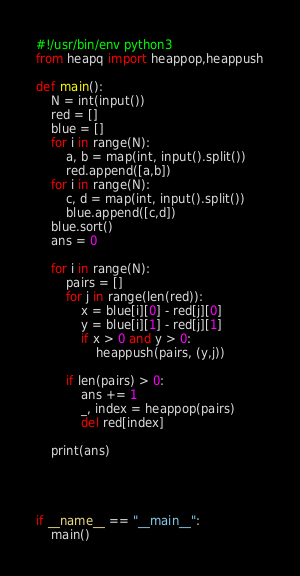<code> <loc_0><loc_0><loc_500><loc_500><_Python_>#!/usr/bin/env python3
from heapq import heappop,heappush

def main():
    N = int(input())
    red = []
    blue = []
    for i in range(N):
        a, b = map(int, input().split())
        red.append([a,b])
    for i in range(N):
        c, d = map(int, input().split())
        blue.append([c,d])
    blue.sort()
    ans = 0

    for i in range(N):
        pairs = []
        for j in range(len(red)):
            x = blue[i][0] - red[j][0]
            y = blue[i][1] - red[j][1]
            if x > 0 and y > 0:
                heappush(pairs, (y,j))

        if len(pairs) > 0:
            ans += 1
            _, index = heappop(pairs)
            del red[index]
    
    print(ans)


    

if __name__ == "__main__":
    main()
</code> 